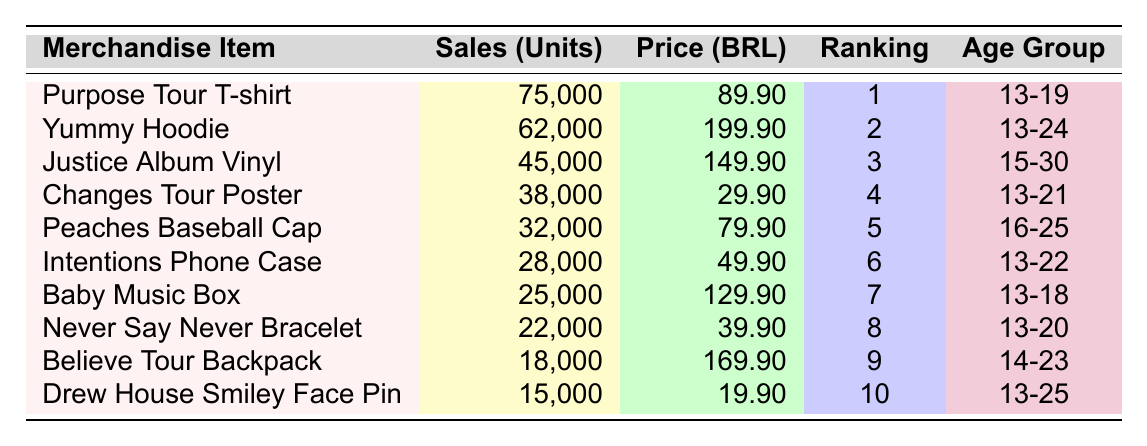What is the most popular merchandise item? The "Purpose Tour T-shirt" has the highest popularity ranking of 1, indicating it is the most popular item in the table.
Answer: Purpose Tour T-shirt How many units of the "Yummy Hoodie" were sold in Brazil? The table lists that 62,000 units of the "Yummy Hoodie" were sold in Brazil.
Answer: 62,000 What is the price of the "Believe Tour Backpack"? The table shows the price of the "Believe Tour Backpack" as 169.90 BRL.
Answer: 169.90 BRL Which merchandise item has the lowest sales? The item with the lowest sales is the "Drew House Smiley Face Pin," with 15,000 units sold.
Answer: Drew House Smiley Face Pin How many units were sold in total for merchandise items aimed at the age group 13-20? Summing up the sales for items aimed at age group 13-20: "Purpose Tour T-shirt" (75,000), "Changes Tour Poster" (38,000), "Intentions Phone Case" (28,000), and "Never Say Never Bracelet" (22,000) gives a total of 163,000 units.
Answer: 163,000 What is the average price of the merchandise items listed in the table? The total price sum is (89.90 + 199.90 + 149.90 + 29.90 + 79.90 + 49.90 + 129.90 + 39.90 + 169.90 + 19.90 = 839.20 BRL) and with 10 items, the average price is 839.20/10 = 83.92 BRL.
Answer: 83.92 BRL Is the "Baby Music Box" more expensive than the "Changes Tour Poster"? The "Baby Music Box" costs 129.90 BRL while the "Changes Tour Poster" is priced at 29.90 BRL, thus the Baby Music Box is more expensive.
Answer: Yes Which merchandise items are aimed at the age group 13-24? The "Yummy Hoodie" (13-24) and the "Intentions Phone Case" (13-22) belong to the age group 13-24.
Answer: Yummy Hoodie, Intentions Phone Case If you combine the sales of the "Purpose Tour T-shirt" and "Yummy Hoodie," how many units were sold? The sales are 75,000 units for the "Purpose Tour T-shirt" and 62,000 for the "Yummy Hoodie," totaling 137,000 units.
Answer: 137,000 Which item has a popularity ranking higher than 5? The items with ranking higher than 5 are the "Justice Album Vinyl," "Changes Tour Poster," "Peaches Baseball Cap," "Intentions Phone Case," "Baby Music Box," "Never Say Never Bracelet," and "Believe Tour Backpack." Their rankings are between 6 and 9.
Answer: Yes 